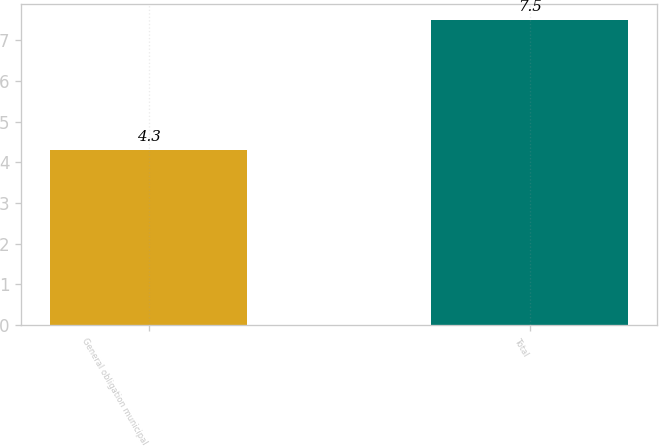Convert chart. <chart><loc_0><loc_0><loc_500><loc_500><bar_chart><fcel>General obligation municipal<fcel>Total<nl><fcel>4.3<fcel>7.5<nl></chart> 